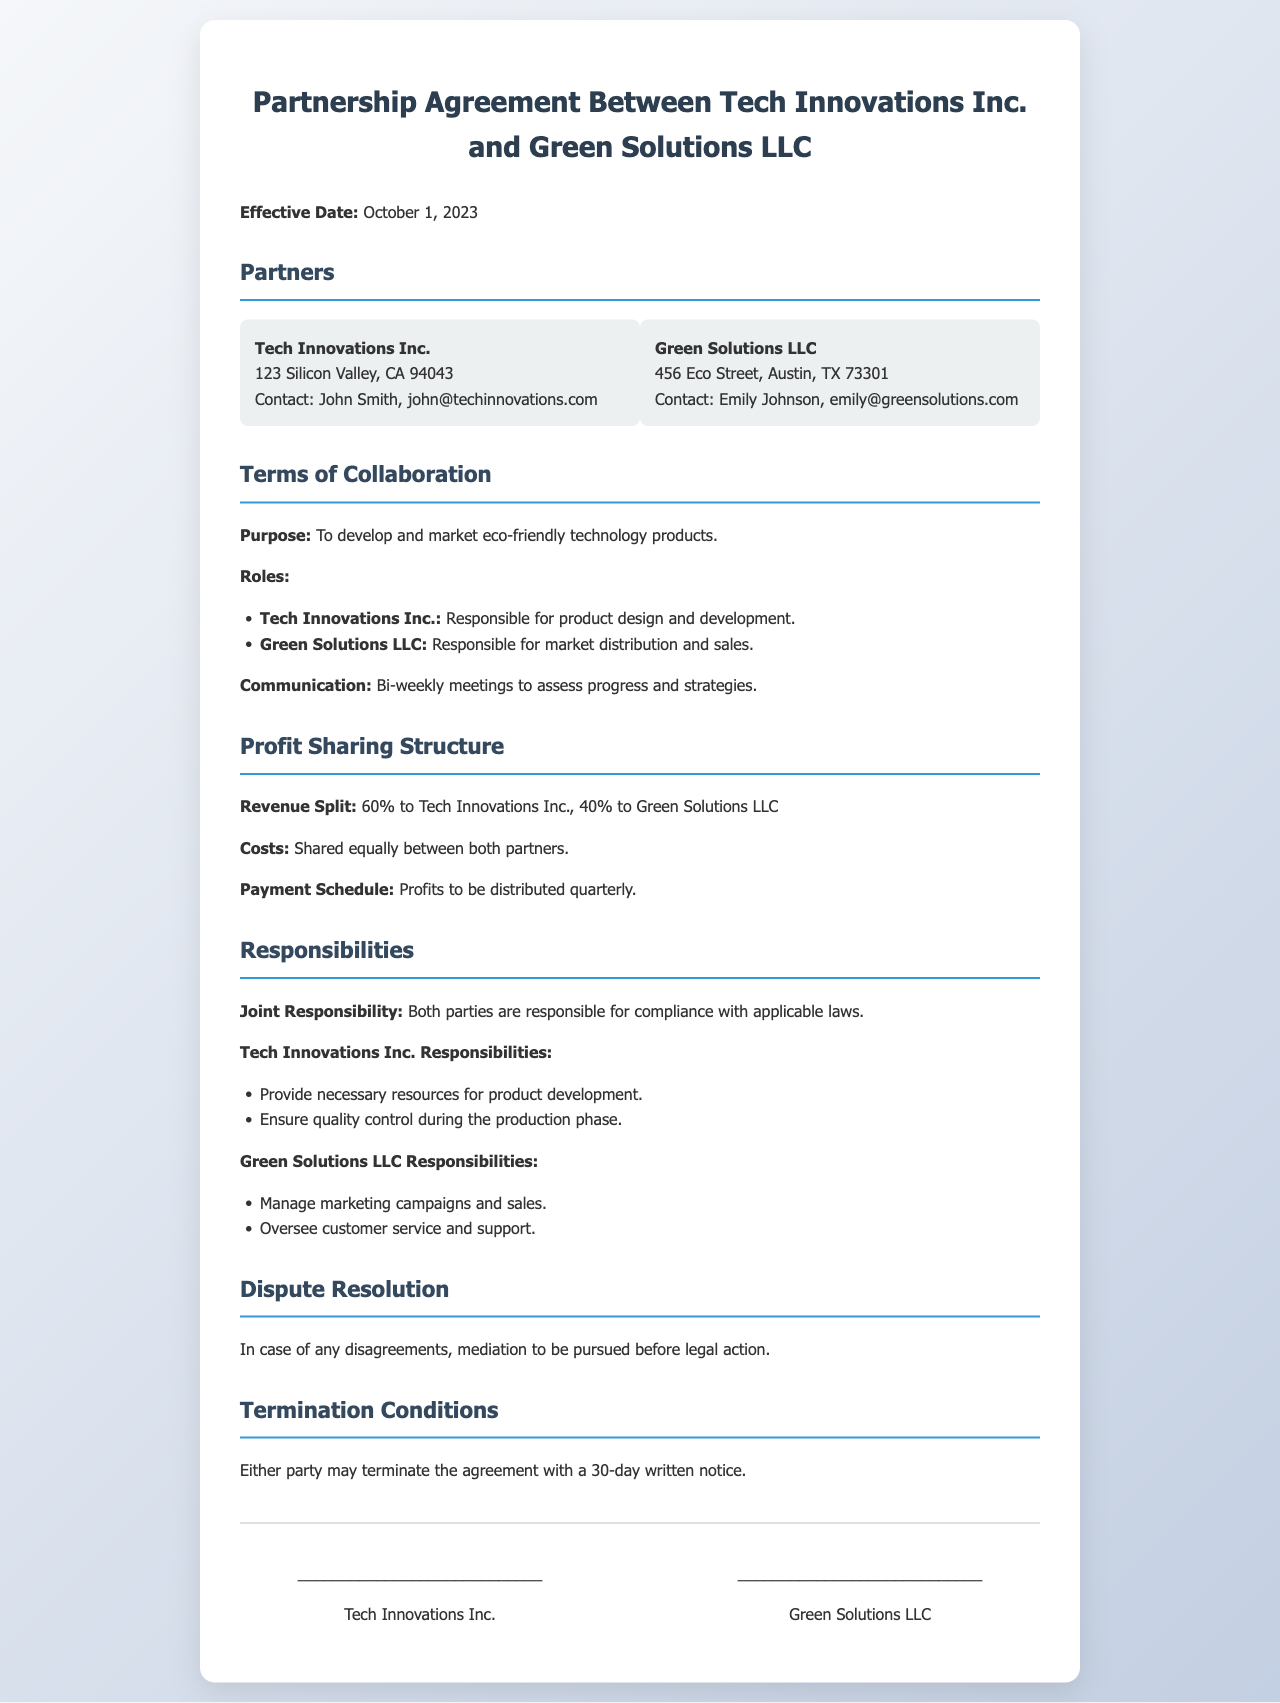What is the effective date of the partnership agreement? The effective date is listed at the beginning of the document.
Answer: October 1, 2023 Who is responsible for product design and development? This information can be found in the roles section under Terms of Collaboration.
Answer: Tech Innovations Inc What is the revenue split between the partners? This detail is specified in the Profit Sharing Structure section.
Answer: 60% to Tech Innovations Inc., 40% to Green Solutions LLC What type of meetings will the partners hold? The type of meetings is mentioned in the communication section of the document.
Answer: Bi-weekly meetings What is the termination notice period for the partnership agreement? The notice period is detailed in the Termination Conditions section.
Answer: 30-day written notice Which partner manages marketing campaigns and sales? This responsibility is outlined under the responsibilities of Green Solutions LLC.
Answer: Green Solutions LLC How often are profits to be distributed? The frequency of profit distribution is mentioned in the Payment Schedule.
Answer: Quarterly What should be pursued in case of disagreements? This procedure is stated in the Dispute Resolution section.
Answer: Mediation 